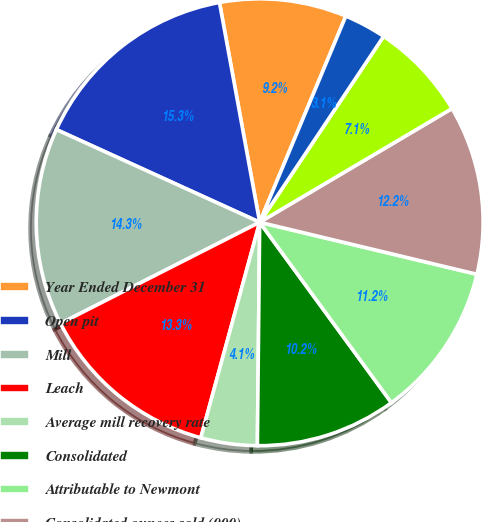<chart> <loc_0><loc_0><loc_500><loc_500><pie_chart><fcel>Year Ended December 31<fcel>Open pit<fcel>Mill<fcel>Leach<fcel>Average mill recovery rate<fcel>Consolidated<fcel>Attributable to Newmont<fcel>Consolidated ounces sold (000)<fcel>Direct mining and production<fcel>By-product credits<nl><fcel>9.18%<fcel>15.31%<fcel>14.29%<fcel>13.27%<fcel>4.08%<fcel>10.2%<fcel>11.22%<fcel>12.24%<fcel>7.14%<fcel>3.06%<nl></chart> 